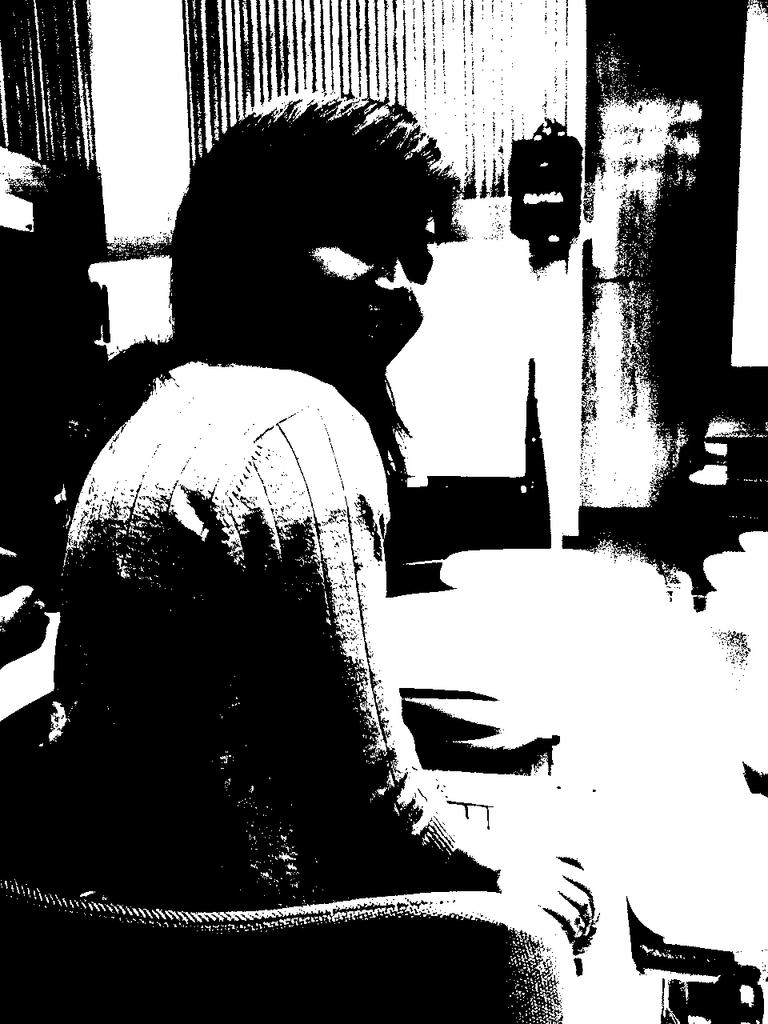Who is the main subject in the image? There is a woman in the image. What is the woman doing in the image? The woman is sitting on a chair. What is the color scheme of the image? The image is in black and white. What can be seen in the background of the image? There is a wall and a window in the background of the image. What type of cork is the woman using to style her hair in the image? There is no cork or hair styling activity present in the image. What type of authority does the woman have in the image? There is no indication of authority or any hierarchical structure in the image. 